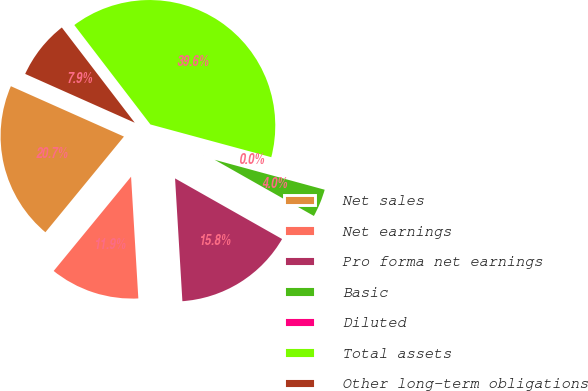Convert chart. <chart><loc_0><loc_0><loc_500><loc_500><pie_chart><fcel>Net sales<fcel>Net earnings<fcel>Pro forma net earnings<fcel>Basic<fcel>Diluted<fcel>Total assets<fcel>Other long-term obligations<nl><fcel>20.73%<fcel>11.89%<fcel>15.85%<fcel>3.97%<fcel>0.02%<fcel>39.61%<fcel>7.93%<nl></chart> 